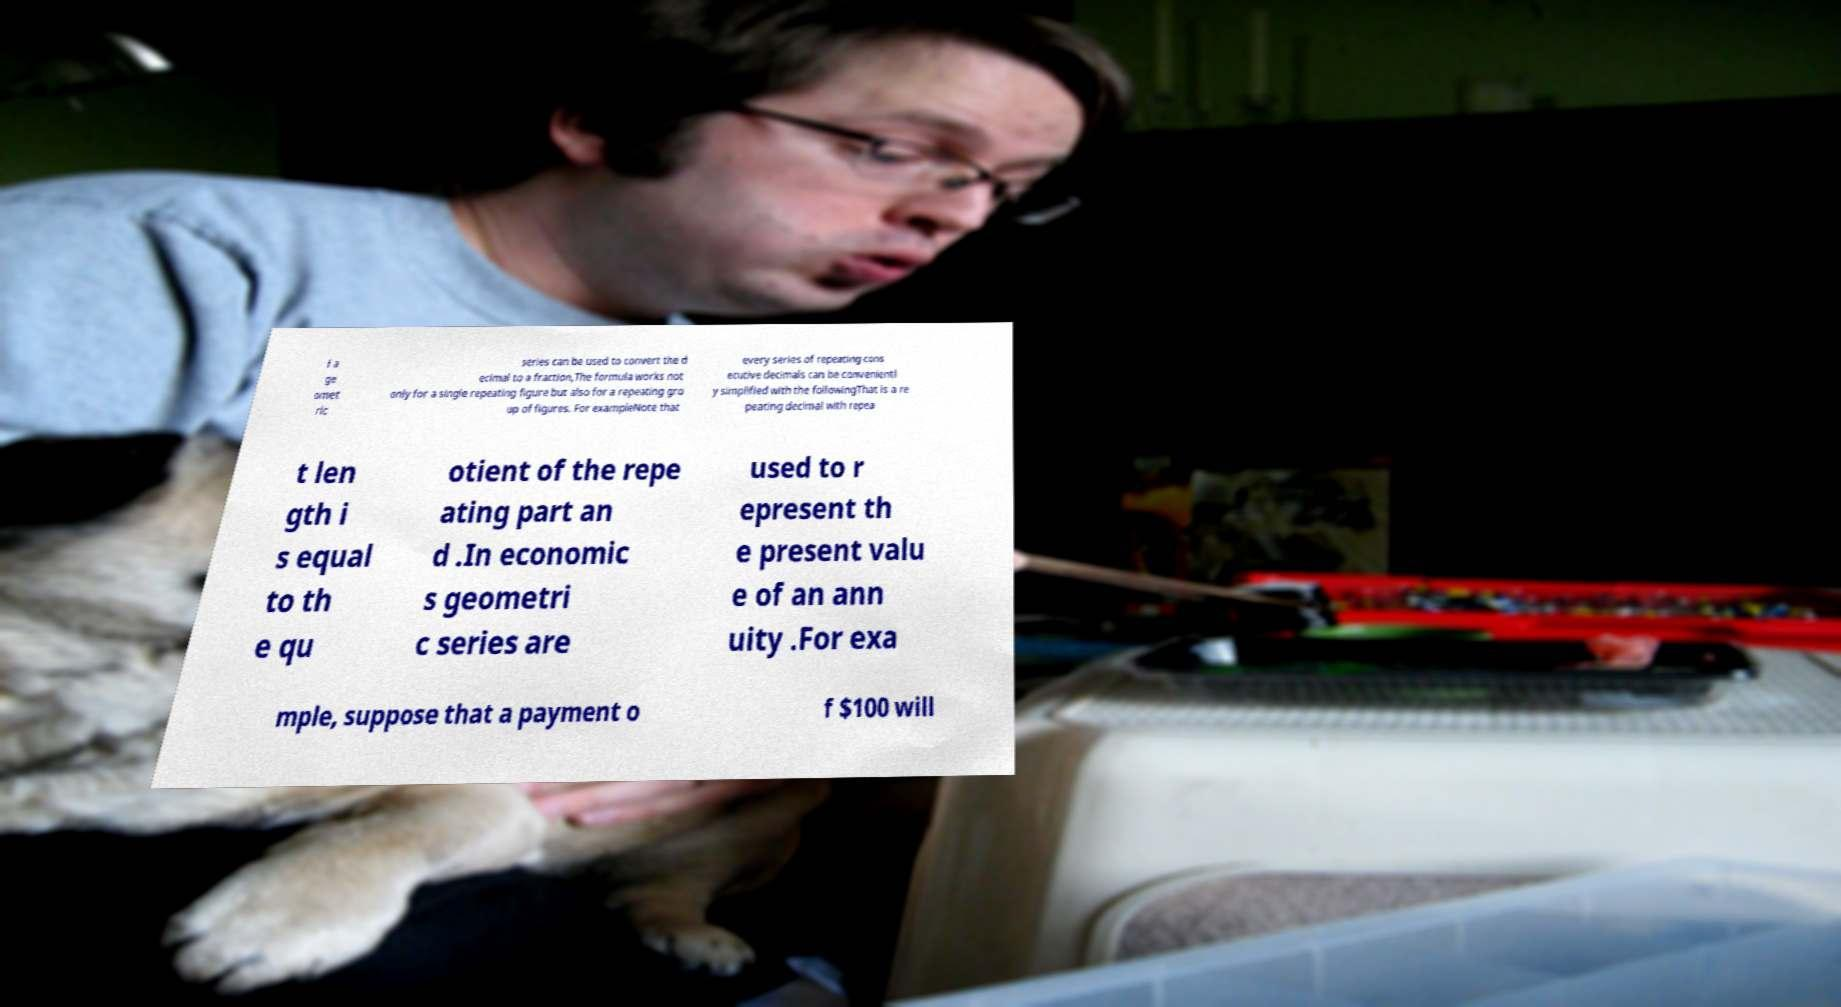Could you assist in decoding the text presented in this image and type it out clearly? f a ge omet ric series can be used to convert the d ecimal to a fraction,The formula works not only for a single repeating figure but also for a repeating gro up of figures. For exampleNote that every series of repeating cons ecutive decimals can be convenientl y simplified with the followingThat is a re peating decimal with repea t len gth i s equal to th e qu otient of the repe ating part an d .In economic s geometri c series are used to r epresent th e present valu e of an ann uity .For exa mple, suppose that a payment o f $100 will 